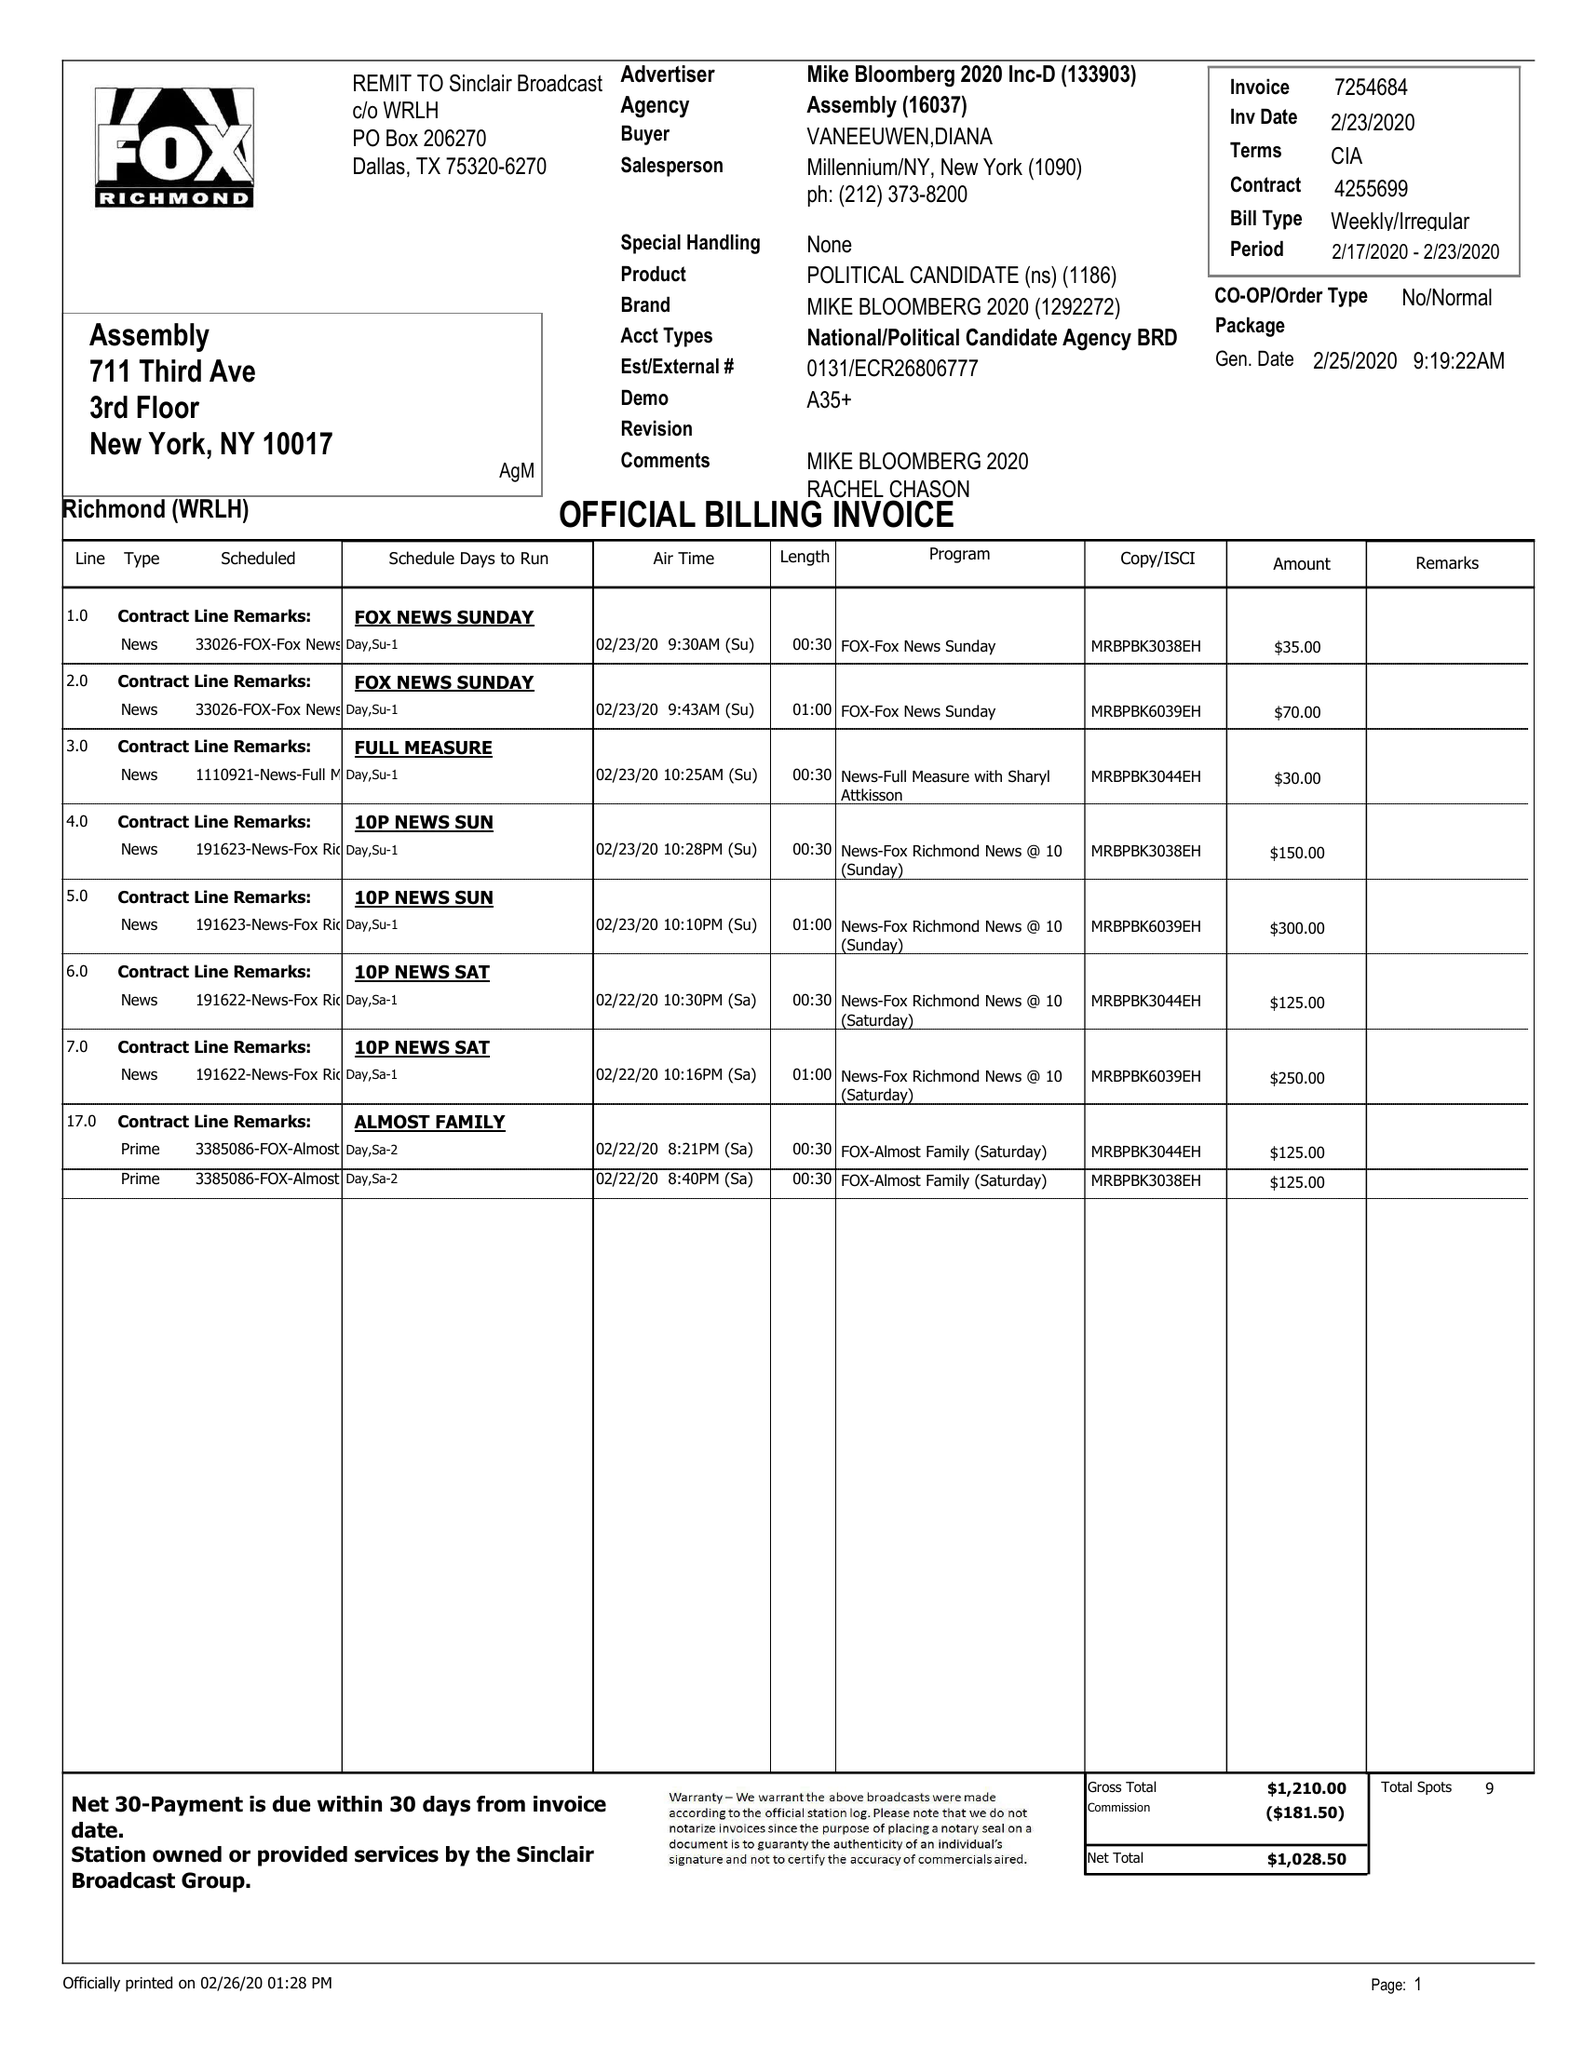What is the value for the flight_from?
Answer the question using a single word or phrase. 02/17/20 